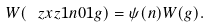<formula> <loc_0><loc_0><loc_500><loc_500>W ( \ z x z { 1 } { n } { 0 } { 1 } g ) = \psi ( n ) W ( g ) .</formula> 